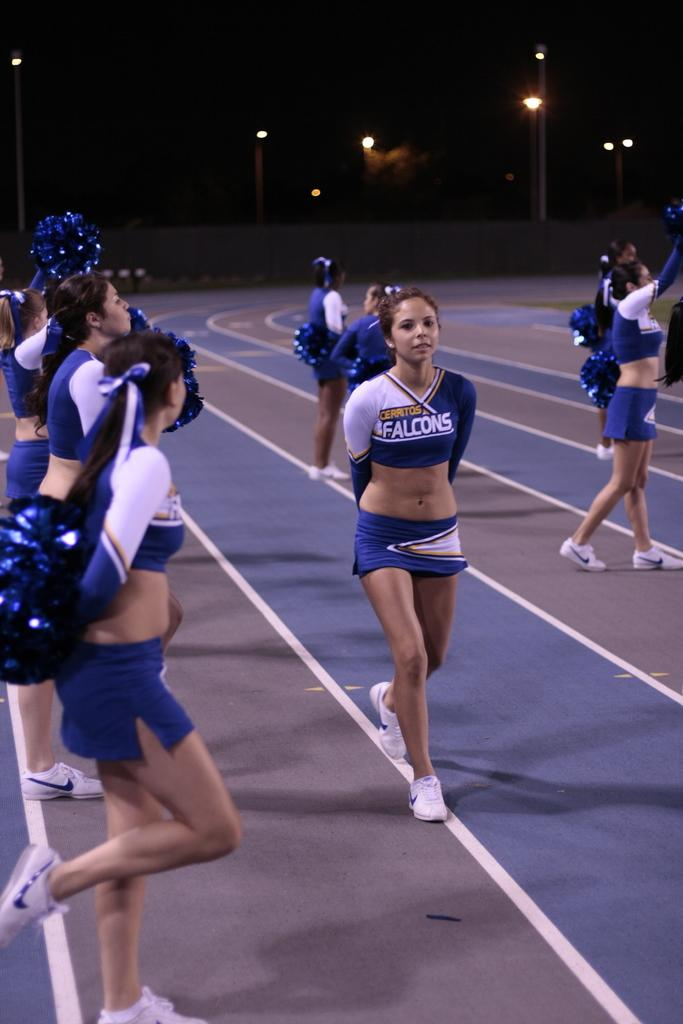<image>
Render a clear and concise summary of the photo. Several cheerleaders are on a track, representing the Falcons. 